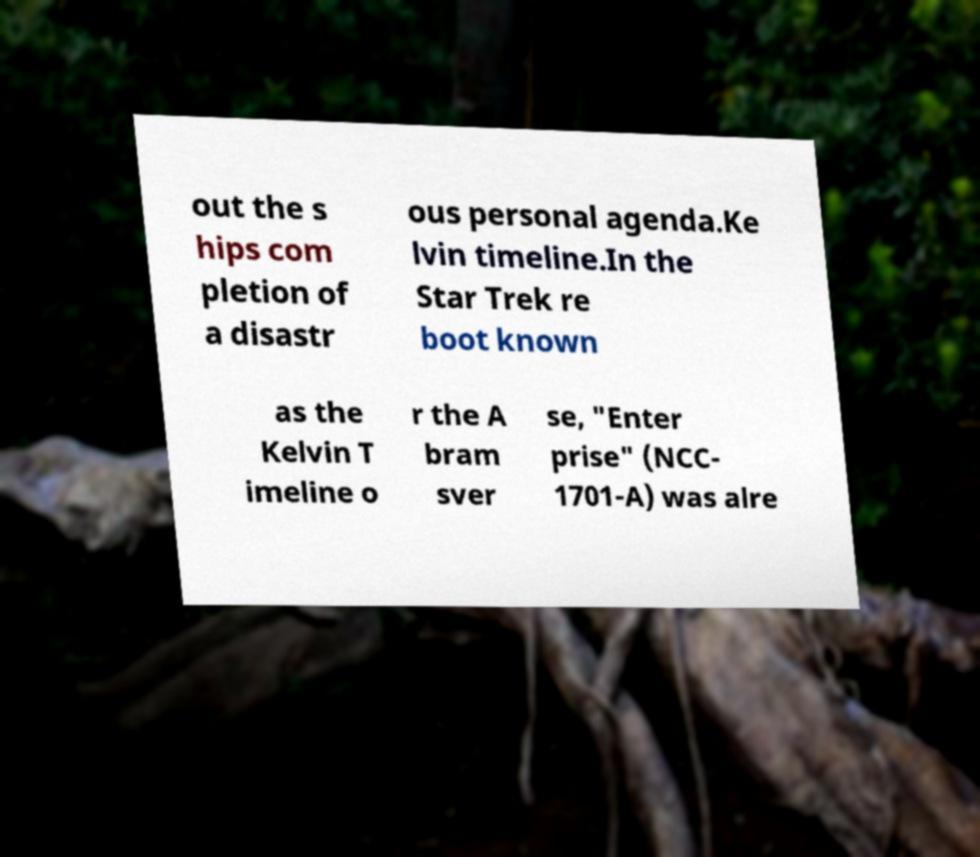Please read and relay the text visible in this image. What does it say? out the s hips com pletion of a disastr ous personal agenda.Ke lvin timeline.In the Star Trek re boot known as the Kelvin T imeline o r the A bram sver se, "Enter prise" (NCC- 1701-A) was alre 